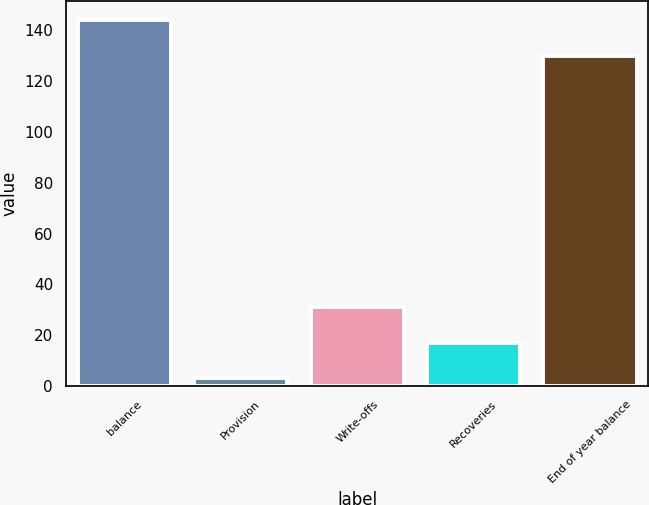Convert chart. <chart><loc_0><loc_0><loc_500><loc_500><bar_chart><fcel>balance<fcel>Provision<fcel>Write-offs<fcel>Recoveries<fcel>End of year balance<nl><fcel>144.1<fcel>3<fcel>31.2<fcel>17.1<fcel>130<nl></chart> 